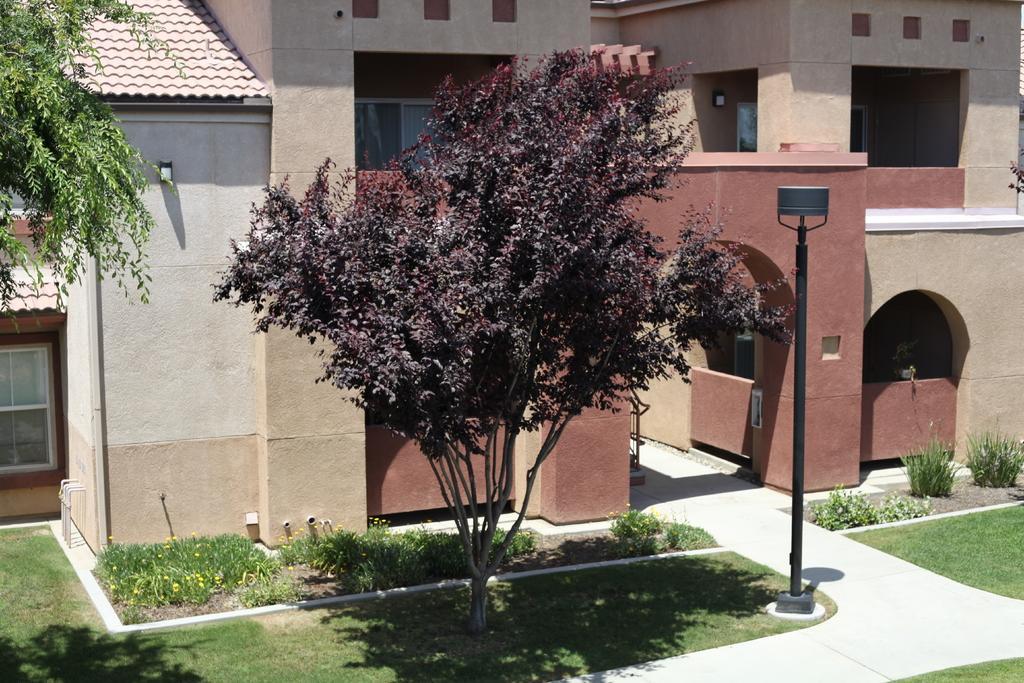Describe this image in one or two sentences. In this image we can see the buildings, windows and arches. We can see the grass, plants and trees. We can see the black color poles and roofing. 